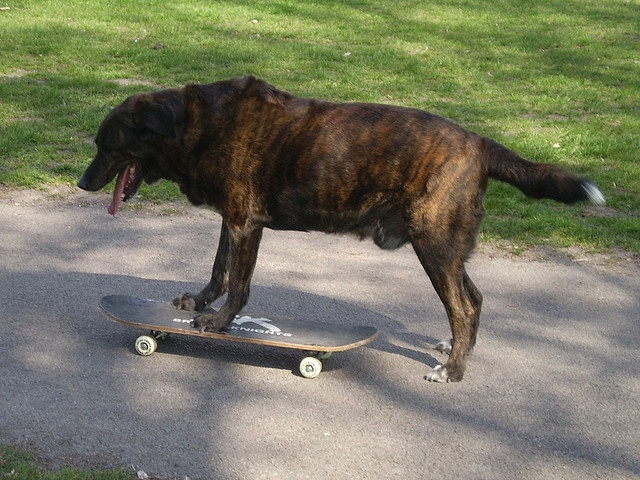Describe the objects in this image and their specific colors. I can see dog in olive, black, maroon, and gray tones and skateboard in olive, gray, darkgray, and ivory tones in this image. 